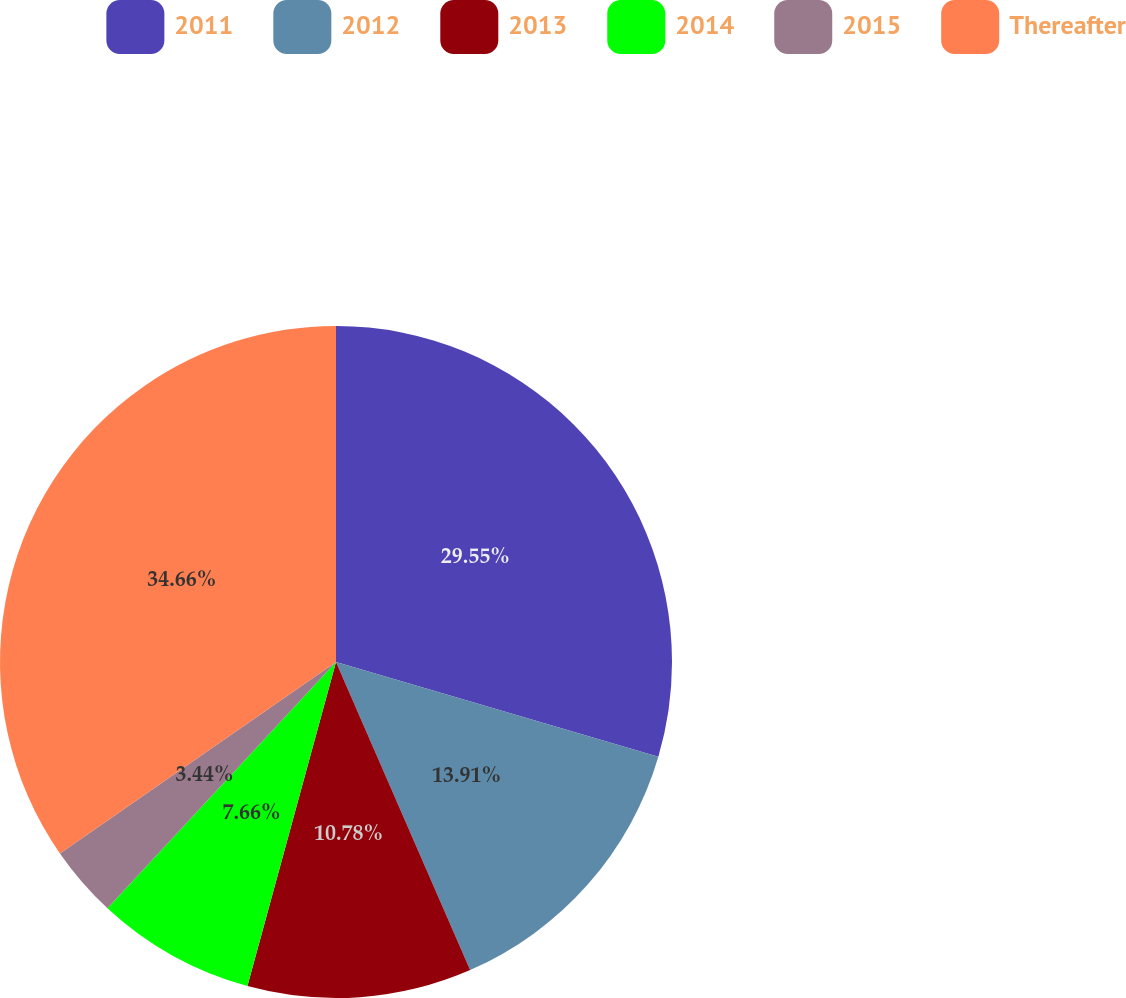Convert chart to OTSL. <chart><loc_0><loc_0><loc_500><loc_500><pie_chart><fcel>2011<fcel>2012<fcel>2013<fcel>2014<fcel>2015<fcel>Thereafter<nl><fcel>29.55%<fcel>13.91%<fcel>10.78%<fcel>7.66%<fcel>3.44%<fcel>34.65%<nl></chart> 